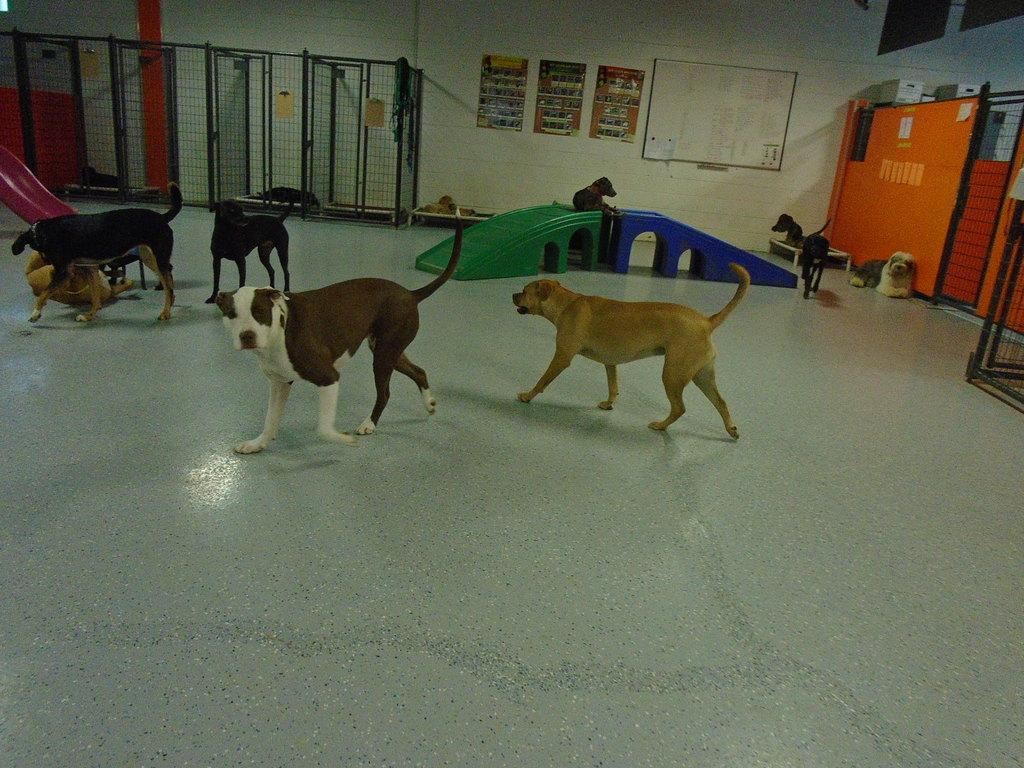What animals are present in the image? There are dogs in the image. How are the dogs positioned in the image? Some dogs are standing on the floor, and one dog is sitting on a plastic box. What can be seen in the background of the image? There are iron cages and charts pasted on the wall visible in the background. How many rabbits can be seen playing with the duck in the image? There are no rabbits or ducks present in the image; it features dogs and the background elements mentioned earlier. 